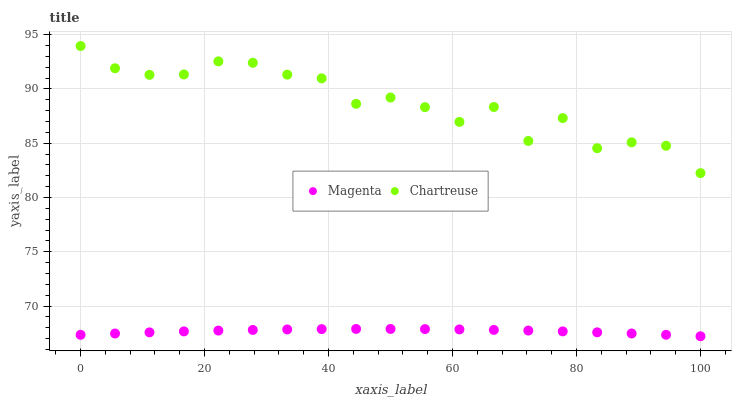Does Magenta have the minimum area under the curve?
Answer yes or no. Yes. Does Chartreuse have the maximum area under the curve?
Answer yes or no. Yes. Does Chartreuse have the minimum area under the curve?
Answer yes or no. No. Is Magenta the smoothest?
Answer yes or no. Yes. Is Chartreuse the roughest?
Answer yes or no. Yes. Is Chartreuse the smoothest?
Answer yes or no. No. Does Magenta have the lowest value?
Answer yes or no. Yes. Does Chartreuse have the lowest value?
Answer yes or no. No. Does Chartreuse have the highest value?
Answer yes or no. Yes. Is Magenta less than Chartreuse?
Answer yes or no. Yes. Is Chartreuse greater than Magenta?
Answer yes or no. Yes. Does Magenta intersect Chartreuse?
Answer yes or no. No. 